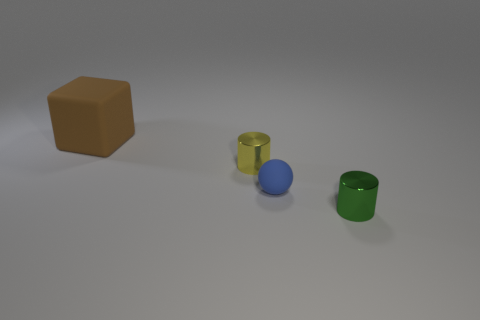Is there anything else that has the same size as the block?
Provide a short and direct response. No. What is the color of the big thing that is the same material as the tiny ball?
Offer a very short reply. Brown. There is a metal thing behind the small blue rubber object; is it the same size as the brown matte object on the left side of the tiny yellow thing?
Keep it short and to the point. No. How many cylinders are either small yellow metal objects or large rubber things?
Your answer should be compact. 1. Is the sphere that is behind the green shiny cylinder made of the same material as the yellow cylinder?
Provide a succinct answer. No. How many other things are there of the same size as the sphere?
Offer a terse response. 2. How many big things are yellow metal things or blue rubber cylinders?
Your answer should be very brief. 0. Are there more tiny cylinders that are in front of the tiny sphere than yellow shiny cylinders that are behind the big rubber object?
Your response must be concise. Yes. Is the color of the matte object in front of the large brown cube the same as the big rubber cube?
Provide a succinct answer. No. Is there anything else of the same color as the matte cube?
Keep it short and to the point. No. 